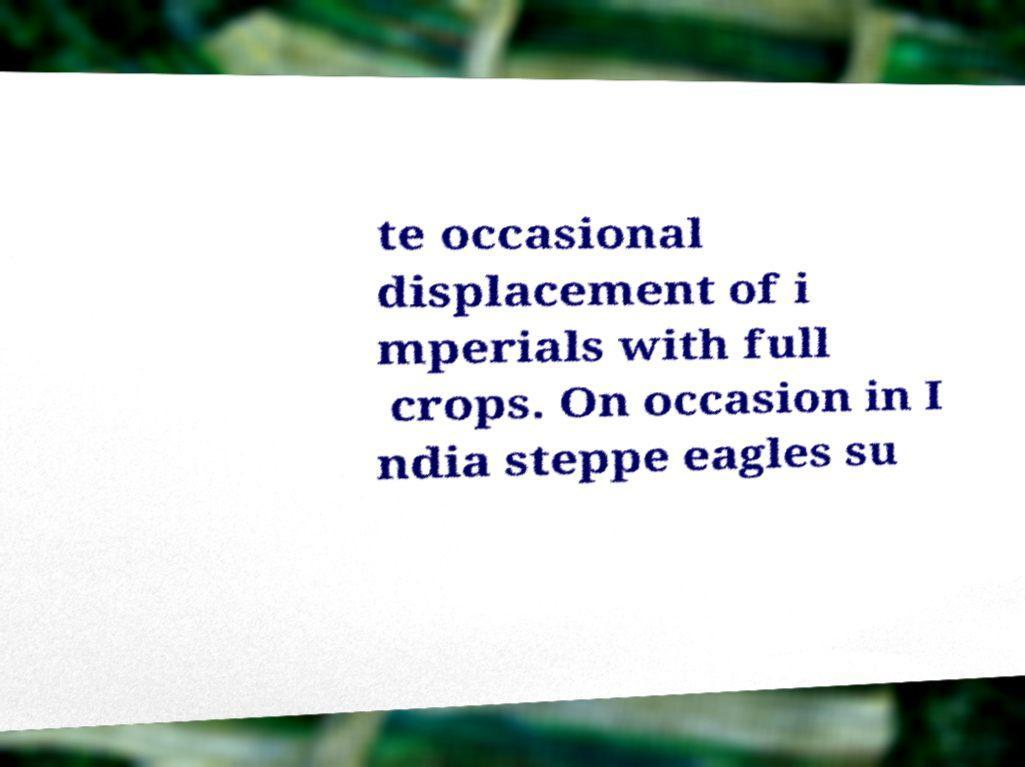I need the written content from this picture converted into text. Can you do that? te occasional displacement of i mperials with full crops. On occasion in I ndia steppe eagles su 